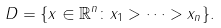<formula> <loc_0><loc_0><loc_500><loc_500>D = \{ x \in \mathbb { R } ^ { n } \colon x _ { 1 } > \cdots > x _ { n } \} .</formula> 